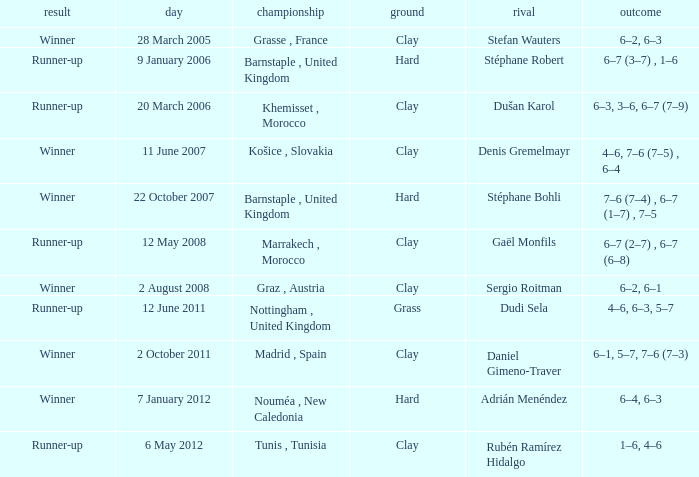What is the surface of the tournament with a runner-up outcome and dudi sela as the opponent? Grass. 